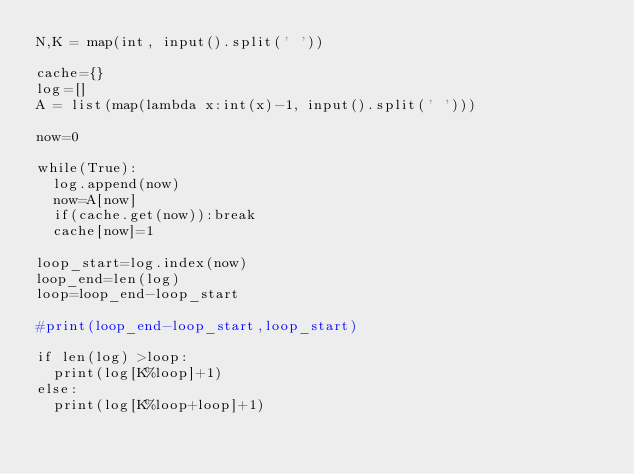Convert code to text. <code><loc_0><loc_0><loc_500><loc_500><_Python_>N,K = map(int, input().split(' '))

cache={}
log=[]
A = list(map(lambda x:int(x)-1, input().split(' ')))

now=0

while(True):
  log.append(now)
  now=A[now]
  if(cache.get(now)):break
  cache[now]=1

loop_start=log.index(now)
loop_end=len(log)
loop=loop_end-loop_start

#print(loop_end-loop_start,loop_start)

if len(log) >loop:
  print(log[K%loop]+1)
else:
  print(log[K%loop+loop]+1)</code> 